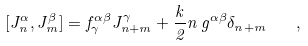<formula> <loc_0><loc_0><loc_500><loc_500>[ J _ { n } ^ { \alpha } , J _ { m } ^ { \beta } ] = f _ { \gamma } ^ { \alpha \beta } J _ { n + m } ^ { \gamma } + \frac { k } { 2 } n \, g ^ { \alpha \beta } \delta _ { n + m } \quad ,</formula> 